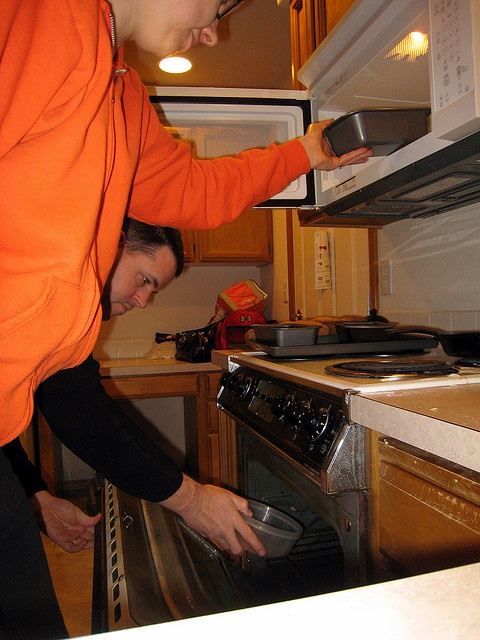Describe the objects in this image and their specific colors. I can see people in red, black, and brown tones, microwave in red, gray, black, tan, and darkgray tones, oven in red, black, maroon, gray, and brown tones, people in red, black, maroon, and brown tones, and bowl in red, black, maroon, and gray tones in this image. 